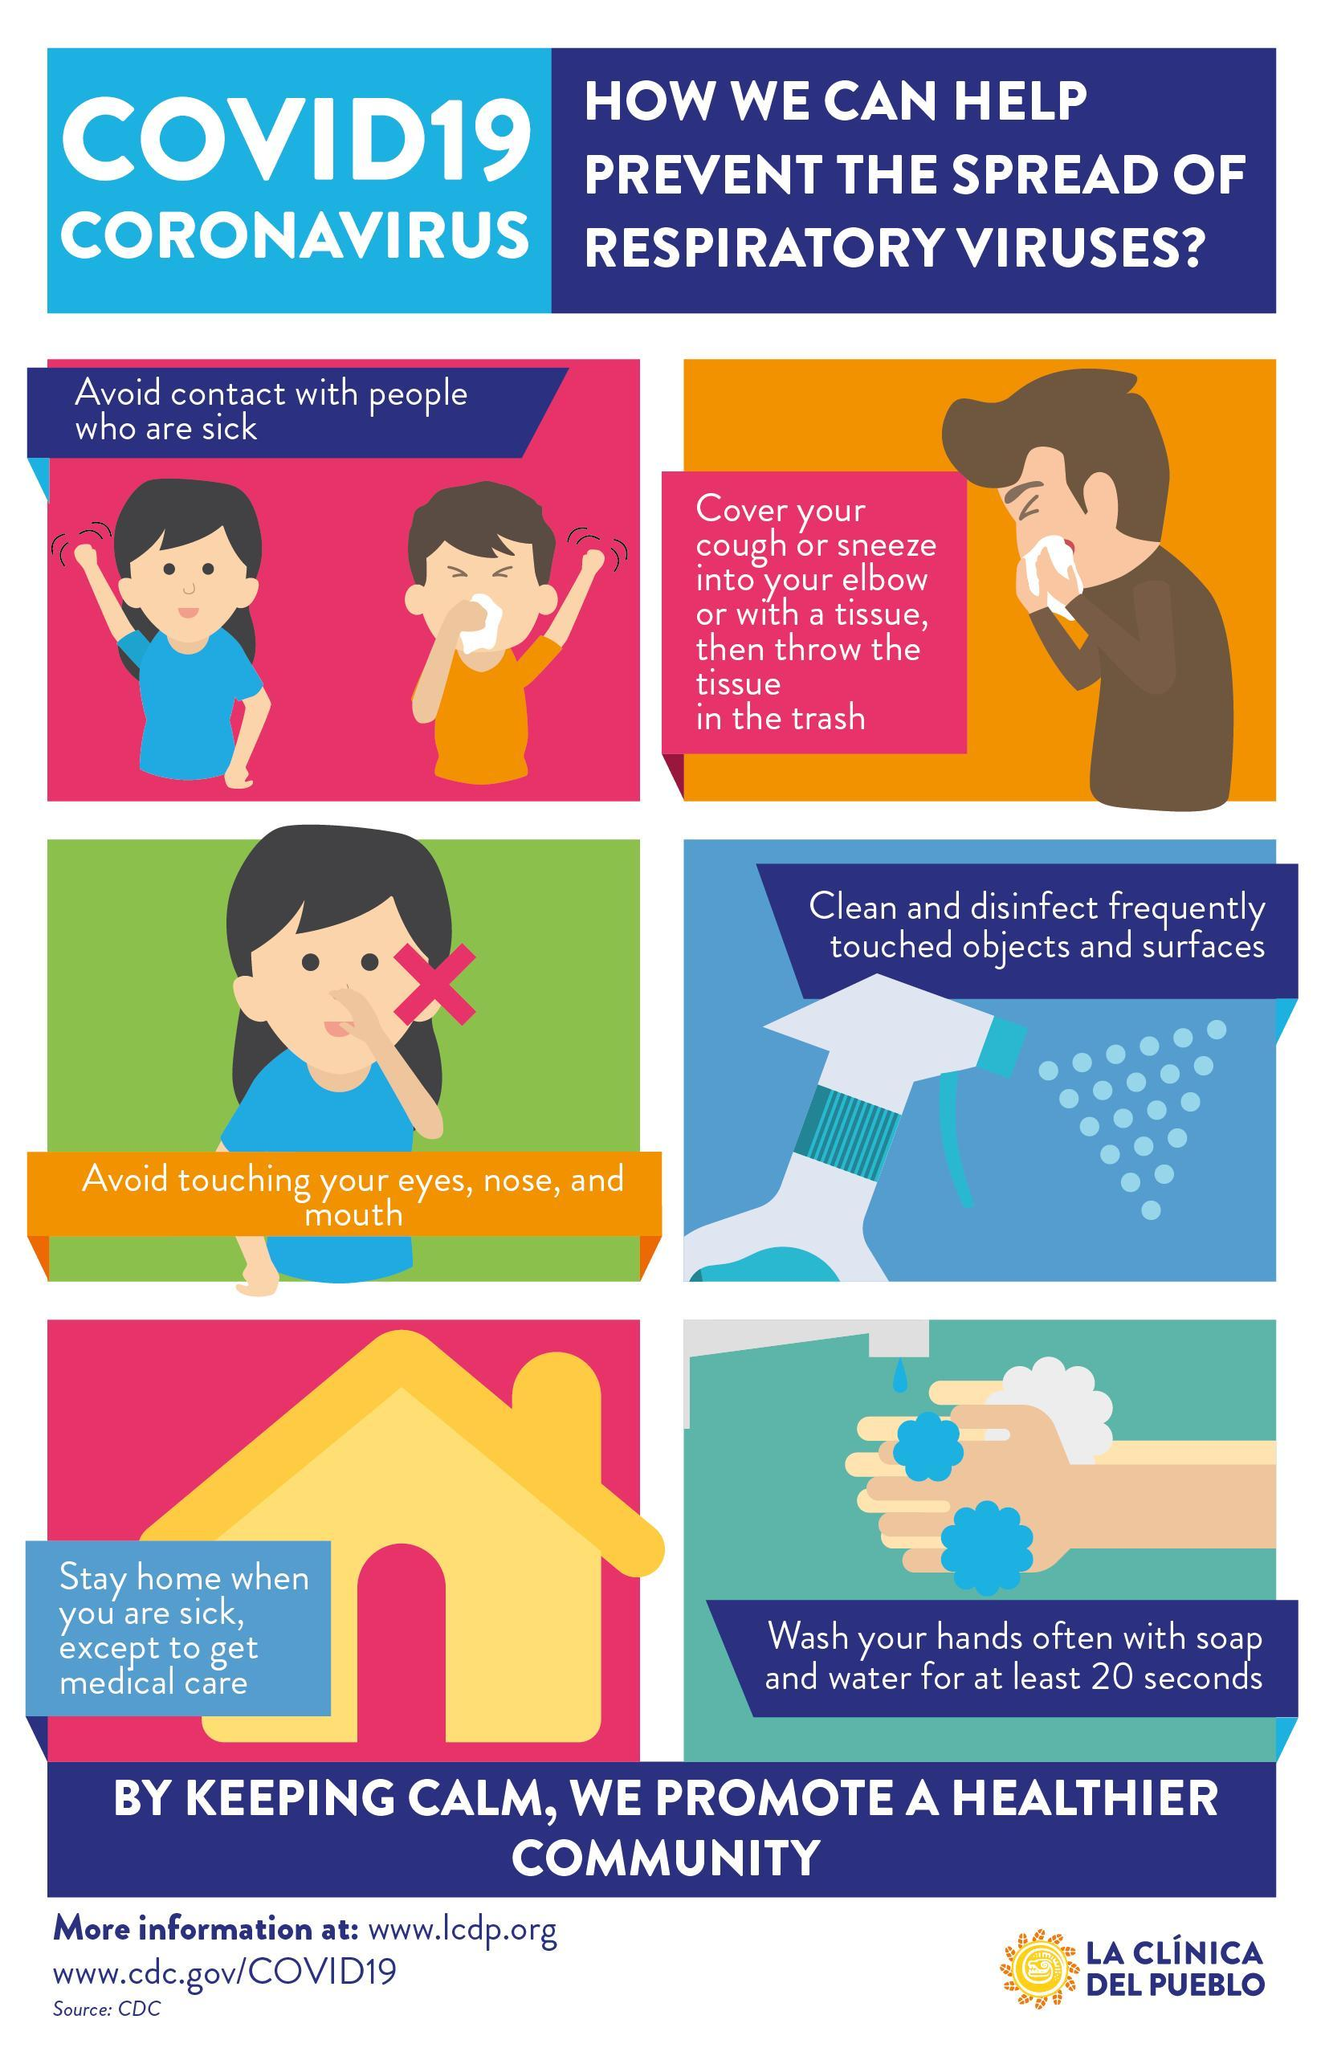How long one should wash their hands in order to prevent the spread of COVID-19?
Answer the question with a short phrase. at least 20 seconds 